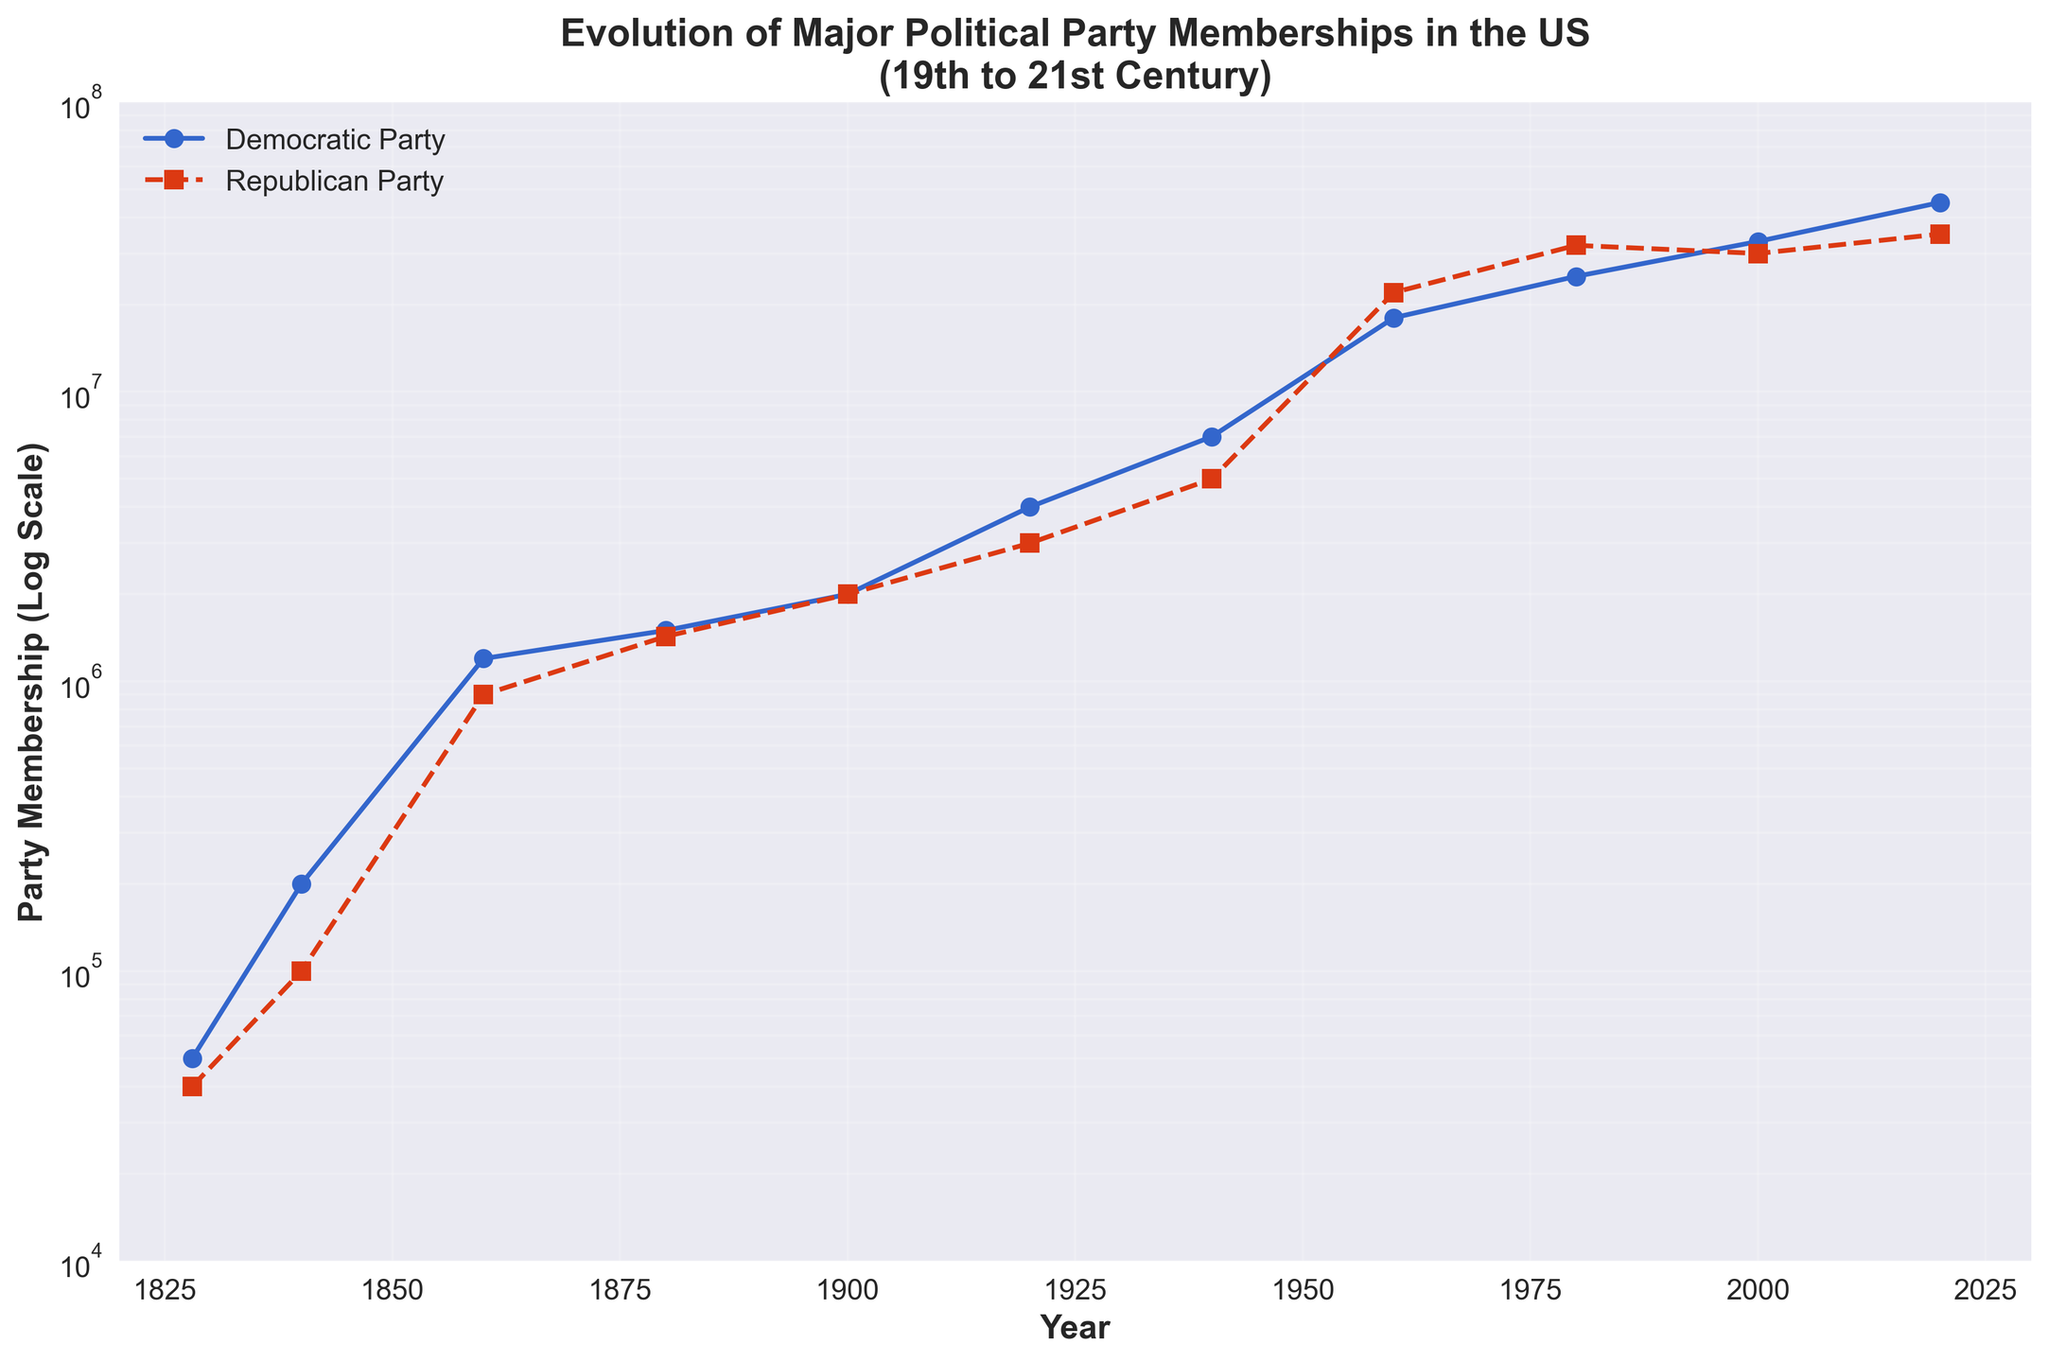what is the title of the figure? The title is located at the top of the figure in larger, bold font and reads "Evolution of Major Political Party Memberships in the US (19th to 21st Century)."
Answer: Evolution of Major Political Party Memberships in the US (19th to 21st Century) What is the general trend for both political parties' memberships from 1828 to 2020? Both parties show an increasing trend in membership over time. The lines for both Democratic and Republican Party membership generally slope upwards.
Answer: Increasing Which political party had a higher membership in 1900? The marker for 1900 shows that both parties had equal membership levels, as indicated by the overlapping points at 2,000,000.
Answer: Both are equal How does the membership of the Democratic Party in 1828 compare to 2020? The Democratic Party's membership in 1828 was 50,000, while in 2020, it was 45,000,000. This is a significant increase over time.
Answer: Increased significantly What is the difference in membership between the Democratic and Republican parties in 1960? The Democratic membership is 18,000,000, and the Republican membership is 22,000,000. Subtracting the two values gives us a difference of 4,000,000.
Answer: 4,000,000 At what approximate membership value do the two parties intersect for the most common tie? Observing the plot, the two parties intersect around 2,000,000 members, as indicated by the convergence of both lines around the year 1900.
Answer: 2,000,000 Which party shows a larger relative growth from 1960 to 2000? Democratic Party membership grew from 18,000,000 in 1960 to 33,000,000 in 2000, while Republican Party membership grew from 22,000,000 in 1960 to 30,000,000 in 2000. The absolute growth for Democrats is 15,000,000 (33-18), while for Republicans, it is 8,000,000 (30-22).
Answer: Democratic Party In what year did the Democratic Party membership first surpass 40 million? The Democratic Party membership first surpassed 40 million in the year 2020, as indicated by the point at 45,000,000.
Answer: 2020 What is the difference in the membership of the Republican Party from 1840 to 2020? The Republican Party membership in 1840 was 100,000, and in 2020, it was 35,000,000. The difference is calculated as 35,000,000 - 100,000 = 34,900,000.
Answer: 34,900,000 